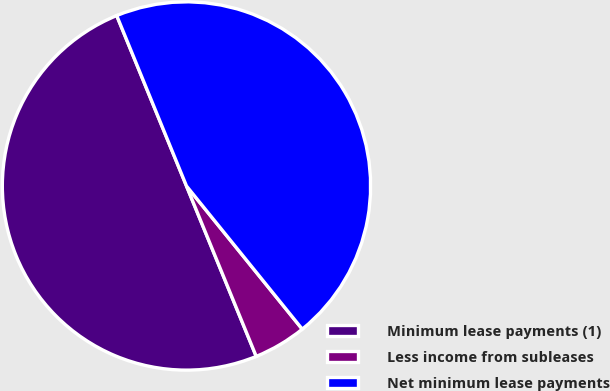Convert chart to OTSL. <chart><loc_0><loc_0><loc_500><loc_500><pie_chart><fcel>Minimum lease payments (1)<fcel>Less income from subleases<fcel>Net minimum lease payments<nl><fcel>50.0%<fcel>4.64%<fcel>45.36%<nl></chart> 